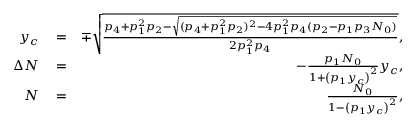Convert formula to latex. <formula><loc_0><loc_0><loc_500><loc_500>\begin{array} { r l r } { y _ { c } } & = } & { \mp \sqrt { \frac { p _ { 4 } + p _ { 1 } ^ { 2 } p _ { 2 } - \sqrt { ( p _ { 4 } + p _ { 1 } ^ { 2 } p _ { 2 } ) ^ { 2 } - 4 p _ { 1 } ^ { 2 } p _ { 4 } ( p _ { 2 } - p _ { 1 } p _ { 3 } N _ { 0 } ) } } { 2 p _ { 1 } ^ { 2 } p _ { 4 } } } , } \\ { \Delta N } & = } & { - \frac { p _ { 1 } N _ { 0 } } { 1 + \left ( p _ { 1 } y _ { c } \right ) ^ { 2 } } y _ { c } , } \\ { N } & = } & { \frac { N _ { 0 } } { 1 - \left ( p _ { 1 } y _ { c } \right ) ^ { 2 } } , } \end{array}</formula> 